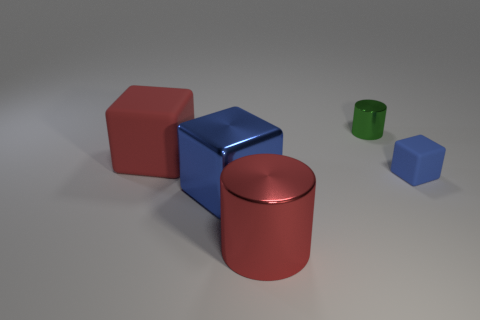Subtract all large red cubes. How many cubes are left? 2 Subtract all blue blocks. How many blocks are left? 1 Subtract all cubes. How many objects are left? 2 Add 1 tiny green shiny things. How many objects exist? 6 Subtract all yellow cylinders. How many blue blocks are left? 2 Add 3 small rubber cubes. How many small rubber cubes exist? 4 Subtract 0 purple cylinders. How many objects are left? 5 Subtract 1 cubes. How many cubes are left? 2 Subtract all gray cylinders. Subtract all blue blocks. How many cylinders are left? 2 Subtract all large gray cubes. Subtract all small metallic objects. How many objects are left? 4 